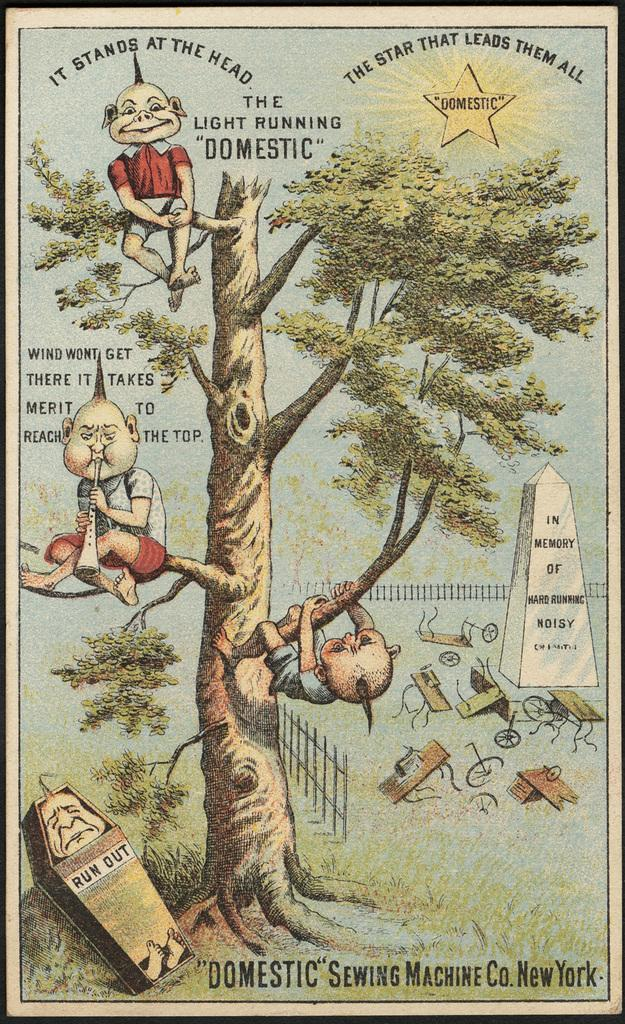What is depicted on the poster in the image? There is a tree on the poster. What type of structure is also shown on the poster? There is a fence on the poster. What other architectural element is present on the poster? There is a wall on the poster. What else can be seen on the poster besides the images? There is writing on the poster. Can you hear the tree playing a musical instrument in the image? There is no indication in the image that the tree is playing a musical instrument, nor is there any sound present. 